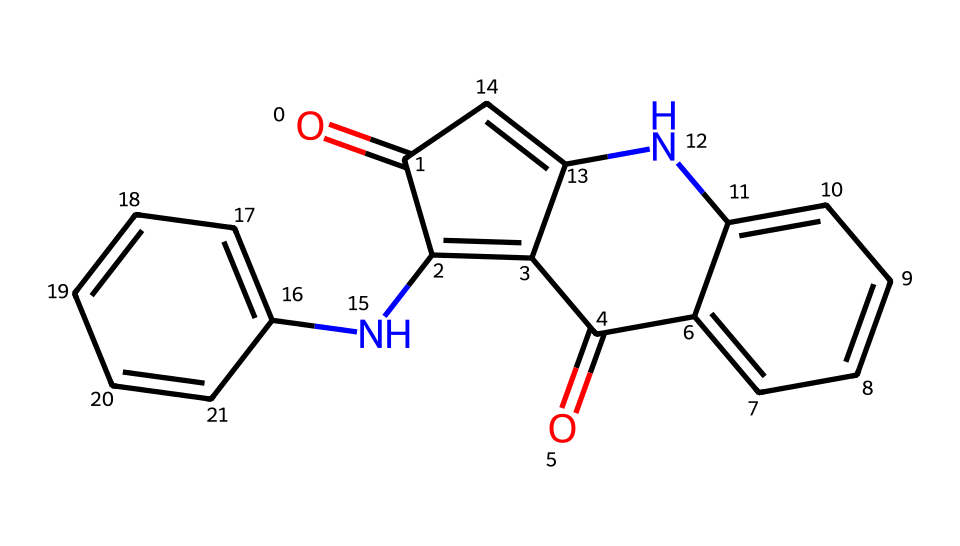What is the molecular formula of indigo? The SMILES representation indicates the presence of various atoms. By analyzing, we can count the number of carbons (C), hydrogens (H), nitrogens (N), and oxygens (O). In this case, there are 16 carbons, 14 hydrogens, 2 nitrogens, and 2 oxygens, leading to the molecular formula C16H10N2O2.
Answer: C16H10N2O2 How many nitrogen atoms are present in indigo? The SMILES structure reveals the presence of nitrogen by identifying 'N' within the representation. There are 2 nitrogen atoms in the molecule.
Answer: 2 What type of bonding is primarily present in the indigo structure? The structure shows multiple double bonds (indicated by '=' signs) and single bonds. However, the presence of aromatic rings means there are significant pi-bonding interactions. This indicates that the primary bonding in indigo includes covalent and aromatic bonding.
Answer: covalent and aromatic What is the characteristic color of indigo? Indigo is widely recognized for its deep blue color, which is a characteristic associated with its chemical structure, particularly its delocalized pi system that interacts with light.
Answer: blue Is indigo soluble in water? Indigo is known to be poorly soluble in water due to its large, hydrophobic aromatic structure, which limits its ability to interact with water molecules.
Answer: poorly soluble What functional groups are present in indigo? Analyzing the structure, we can identify amine (due to the nitrogen attached to carbon) and carbonyl functional groups (due to the 'C=O' connections). Both contribute to the characteristics of indigo.
Answer: amine and carbonyl What makes indigo a desirable dye for eco-friendly textiles? Indigo’s plant-based origin and non-toxic properties make it ideal for eco-friendly textiles. It does not require harsh chemicals for fixing compared to synthetic dyes, making it more sustainable.
Answer: plant-based and non-toxic 